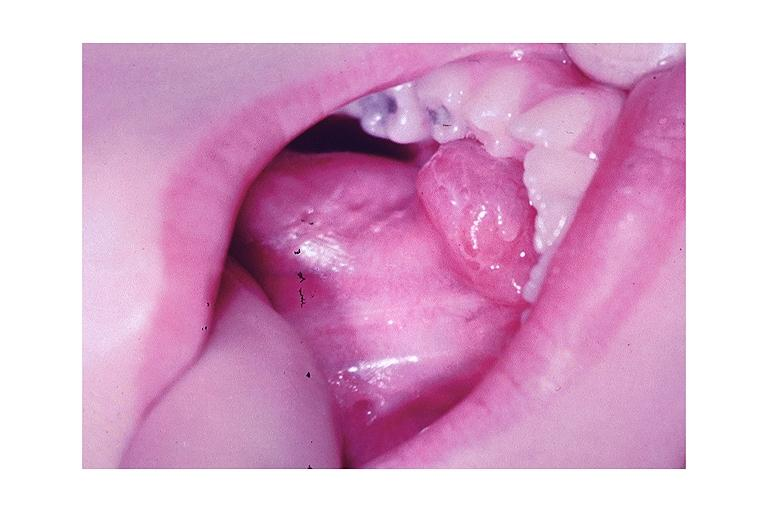s muscle atrophy present?
Answer the question using a single word or phrase. No 